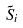Convert formula to latex. <formula><loc_0><loc_0><loc_500><loc_500>\tilde { S } _ { i }</formula> 